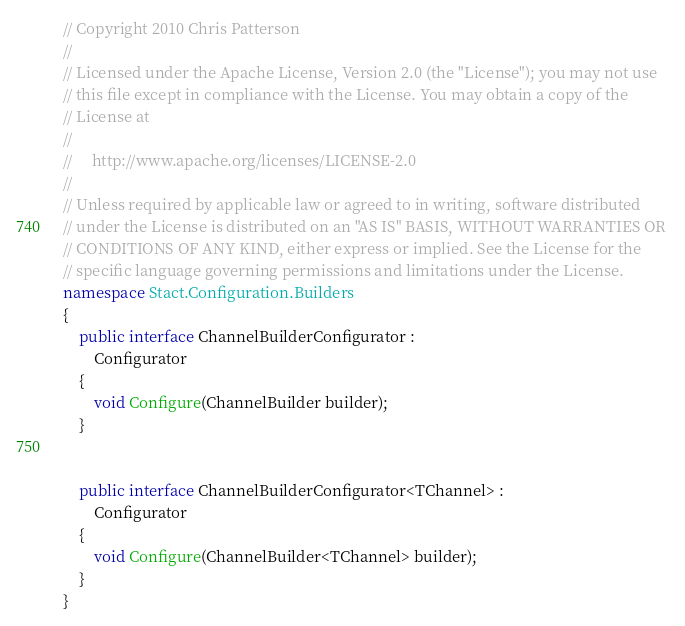<code> <loc_0><loc_0><loc_500><loc_500><_C#_>// Copyright 2010 Chris Patterson
//  
// Licensed under the Apache License, Version 2.0 (the "License"); you may not use 
// this file except in compliance with the License. You may obtain a copy of the 
// License at 
// 
//     http://www.apache.org/licenses/LICENSE-2.0 
// 
// Unless required by applicable law or agreed to in writing, software distributed 
// under the License is distributed on an "AS IS" BASIS, WITHOUT WARRANTIES OR 
// CONDITIONS OF ANY KIND, either express or implied. See the License for the 
// specific language governing permissions and limitations under the License.
namespace Stact.Configuration.Builders
{
	public interface ChannelBuilderConfigurator :
		Configurator
	{
		void Configure(ChannelBuilder builder);
	}


	public interface ChannelBuilderConfigurator<TChannel> :
		Configurator
	{
		void Configure(ChannelBuilder<TChannel> builder);
	}
}</code> 